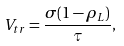<formula> <loc_0><loc_0><loc_500><loc_500>V _ { t r } = \frac { \sigma ( 1 - \rho _ { L } ) } { \tau } ,</formula> 